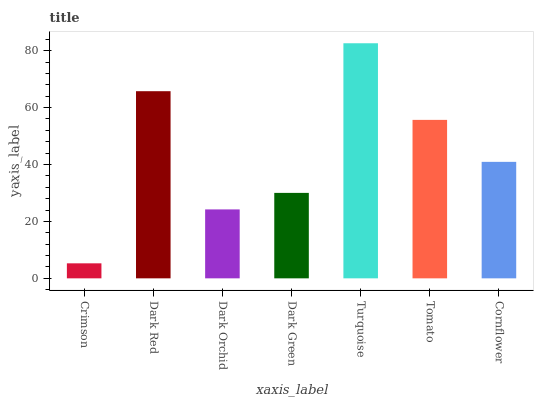Is Crimson the minimum?
Answer yes or no. Yes. Is Turquoise the maximum?
Answer yes or no. Yes. Is Dark Red the minimum?
Answer yes or no. No. Is Dark Red the maximum?
Answer yes or no. No. Is Dark Red greater than Crimson?
Answer yes or no. Yes. Is Crimson less than Dark Red?
Answer yes or no. Yes. Is Crimson greater than Dark Red?
Answer yes or no. No. Is Dark Red less than Crimson?
Answer yes or no. No. Is Cornflower the high median?
Answer yes or no. Yes. Is Cornflower the low median?
Answer yes or no. Yes. Is Tomato the high median?
Answer yes or no. No. Is Crimson the low median?
Answer yes or no. No. 